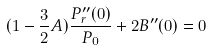Convert formula to latex. <formula><loc_0><loc_0><loc_500><loc_500>( 1 - \frac { 3 } { 2 } A ) \frac { P _ { r } ^ { \prime \prime } ( 0 ) } { P _ { 0 } } + 2 B ^ { \prime \prime } ( 0 ) = 0</formula> 